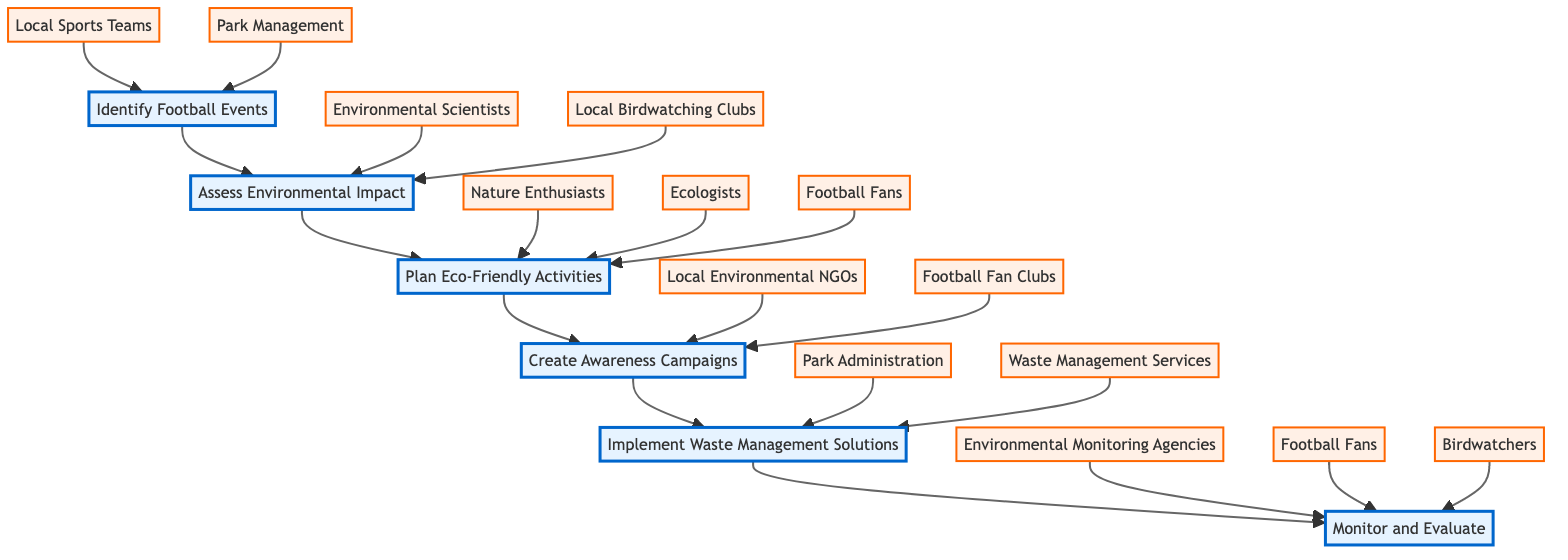What is the first stage in the flow chart? The flow chart starts with the stage labeled "Identify Football Events," which is the first node in the sequence.
Answer: Identify Football Events How many total stages are there in the diagram? The diagram consists of six stages, which can be counted from the nodes represented in the flow chart.
Answer: 6 Which entities are associated with the stage "Plan Eco-Friendly Activities"? The entities linked to the "Plan Eco-Friendly Activities" stage are "Nature Enthusiasts," "Ecologists," and "Football Fans," showing the key players involved at this stage.
Answer: Nature Enthusiasts, Ecologists, Football Fans What is the last stage of the flow chart? The final stage in the flow chart is "Monitor and Evaluate," which is positioned at the end of the sequence of stages.
Answer: Monitor and Evaluate Which stage follows "Create Awareness Campaigns"? The next stage after "Create Awareness Campaigns" is "Implement Waste Management Solutions," following the flow of the diagram.
Answer: Implement Waste Management Solutions What is the relationship between "Assess Environmental Impact" and "Local Birdwatching Clubs"? "Local Birdwatching Clubs" is an entity directly connected to "Assess Environmental Impact," indicating their involvement in evaluating the environmental impact of fan activities.
Answer: Local Birdwatching Clubs Which stage has two entities associated with it? The stage "Implement Waste Management Solutions" has two entities: "Park Administration" and "Waste Management Services," indicating the collaboration at this point.
Answer: Implement Waste Management Solutions How does one proceed from "Assess Environmental Impact" to the next stage? After "Assess Environmental Impact," one proceeds to "Plan Eco-Friendly Activities," showing the progression in promoting eco-conservation efforts.
Answer: Plan Eco-Friendly Activities 